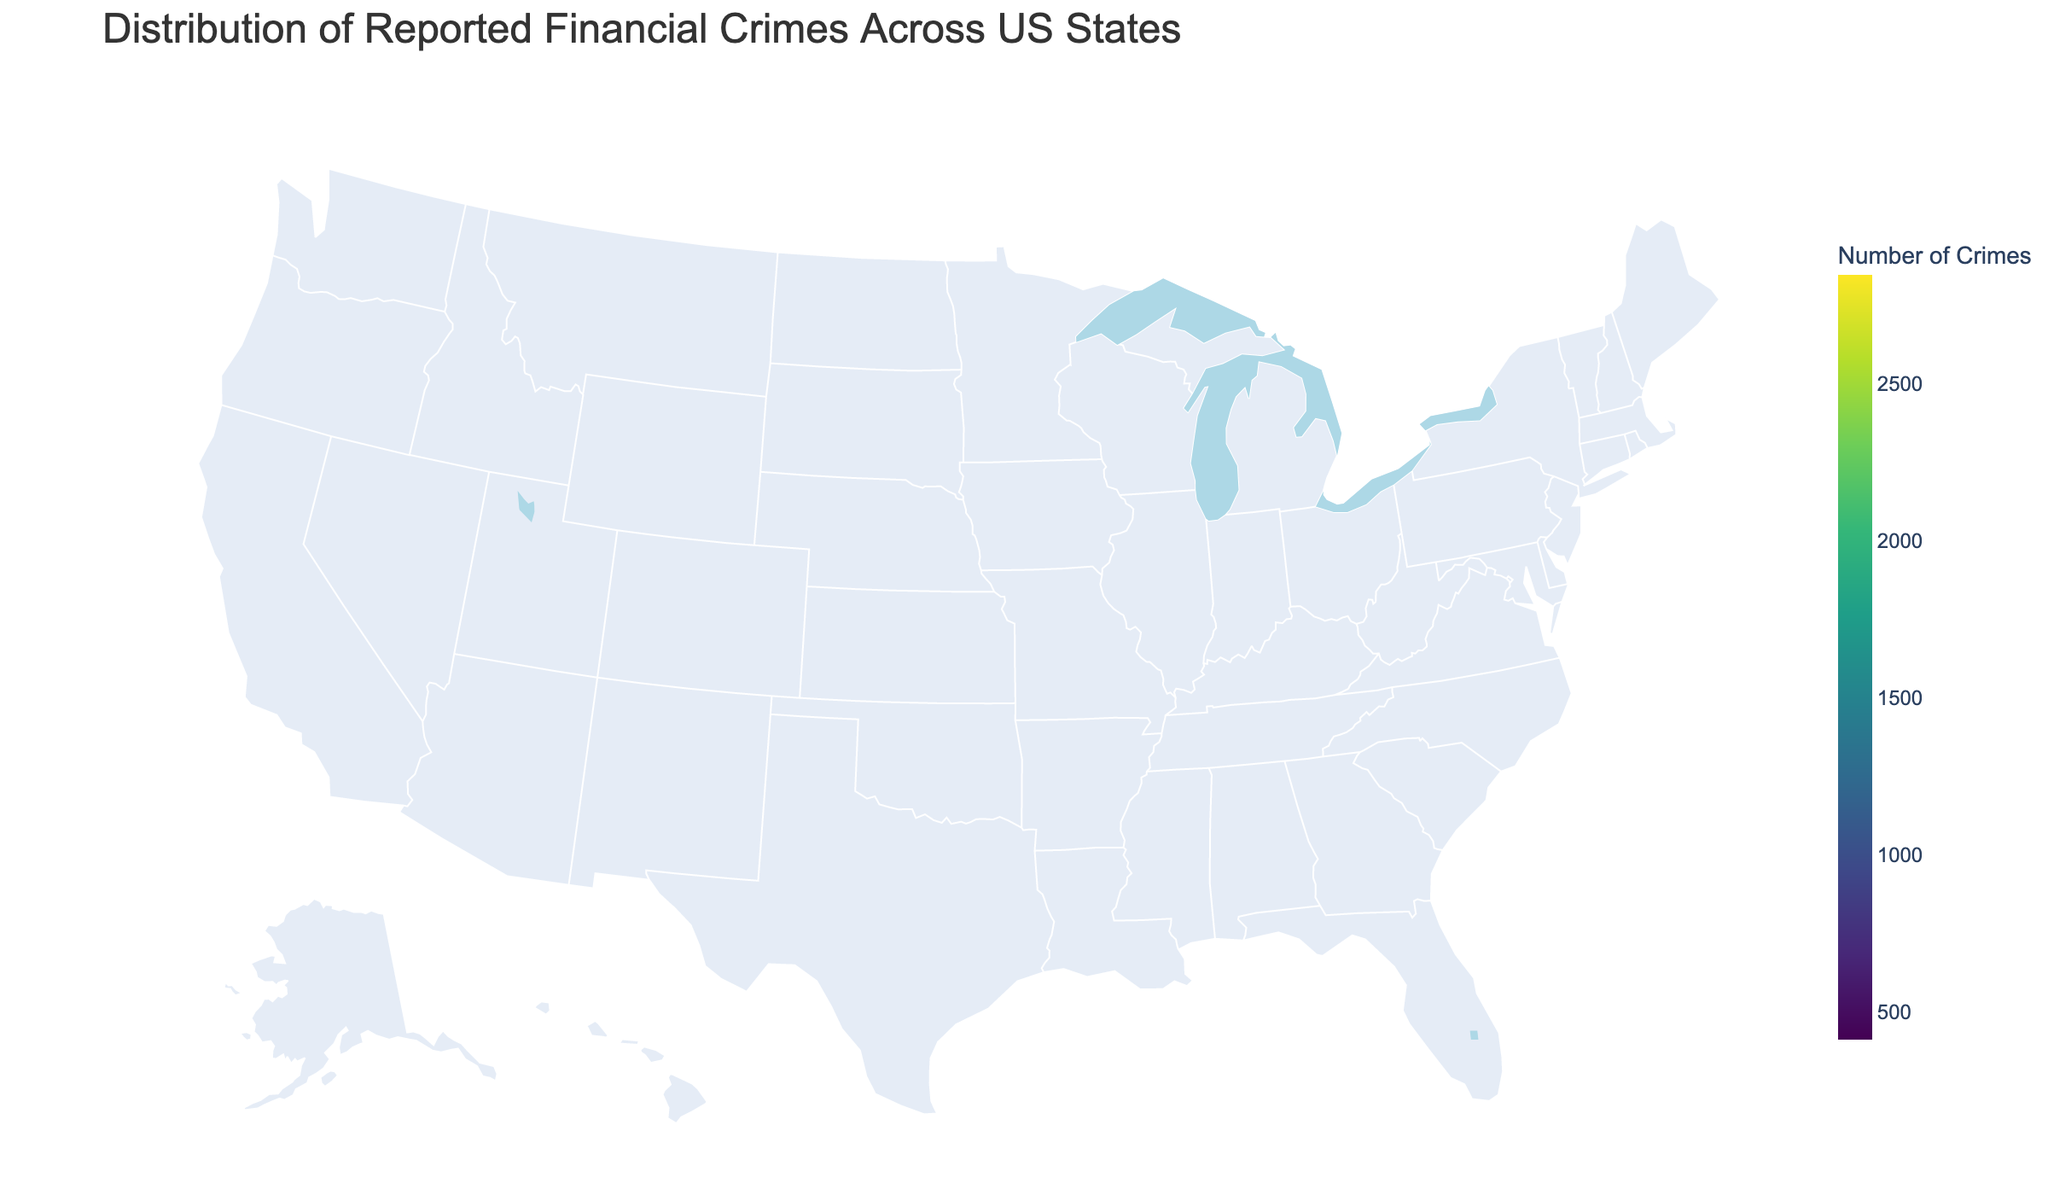Which state has the highest number of reported financial crimes? By identifying the state with the darkest color in the choropleth map, which corresponds to the highest number of reported financial crimes, you can see that California stands out. From the data, California has the most reported financial crimes.
Answer: California What is the total number of reported financial crimes in the top three states? Summing up the reported financial crimes of the top three states: California (2845), New York (2103), and Florida (1987), the total is 2845 + 2103 + 1987.
Answer: 6935 Which state has less reported financial crimes, Ohio or Massachusetts? By comparing the reported financial crimes between Ohio (743) and Massachusetts (865) from the figure, you can see that Ohio has fewer crimes.
Answer: Ohio How does the reported financial crimes in Illinois compare to New Jersey? Illinois has 1342 reported financial crimes, while New Jersey has 1089. Illinois has more reported financial crimes than New Jersey.
Answer: Illinois What is the average number of reported financial crimes across the states listed in the data? To find the average, sum up the reported financial crimes for all states and divide by the number of states: 
(2845 + 2103 + 1987 + 1756 + 1342 + 1089 + 978 + 865 + 743 + 721 + 689 + 651 + 623 + 592 + 541 + 517 + 498 + 456 + 432 + 411) ÷ 20 = 18890 ÷ 20.
Answer: 944.5 Which two states have reported financial crimes numbers closest to each other? By examining the data, Ohio (743) and Georgia (721) have the closest numbers of reported financial crimes, with a small difference of 22.
Answer: Ohio and Georgia How is the color scale in the map helping to differentiate the states? The Viridis color scale maps states with a higher number of reported financial crimes to a darker color, while lighter colors represent states with fewer crimes. This helps in visually differentiating the magnitude of crimes among states.
Answer: Darker colors denote more crimes, lighter colors denote fewer crimes Which state with over 1000 reported financial crimes has the lowest figures? From the data, New Jersey has 1089 reported financial crimes, which is the lowest among states with over 1000 reported crimes.
Answer: New Jersey 